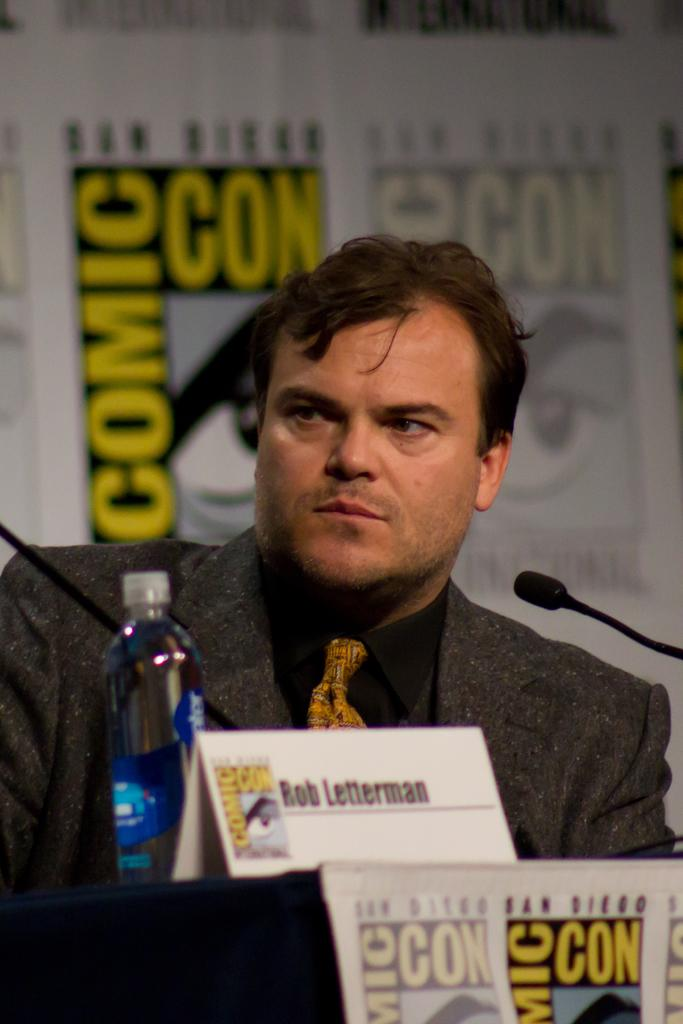Who is present in the image? There is a man in the image. What is the man standing in front of? The man is in front of a table. What items can be seen on the table? There is a water bottle and a board on the table. What can be seen in the background of the image? There is a speaker and hoardings in the background. What is the chance of the man escaping from jail in the image? There is no mention of a jail or any indication that the man is in jail in the image. 